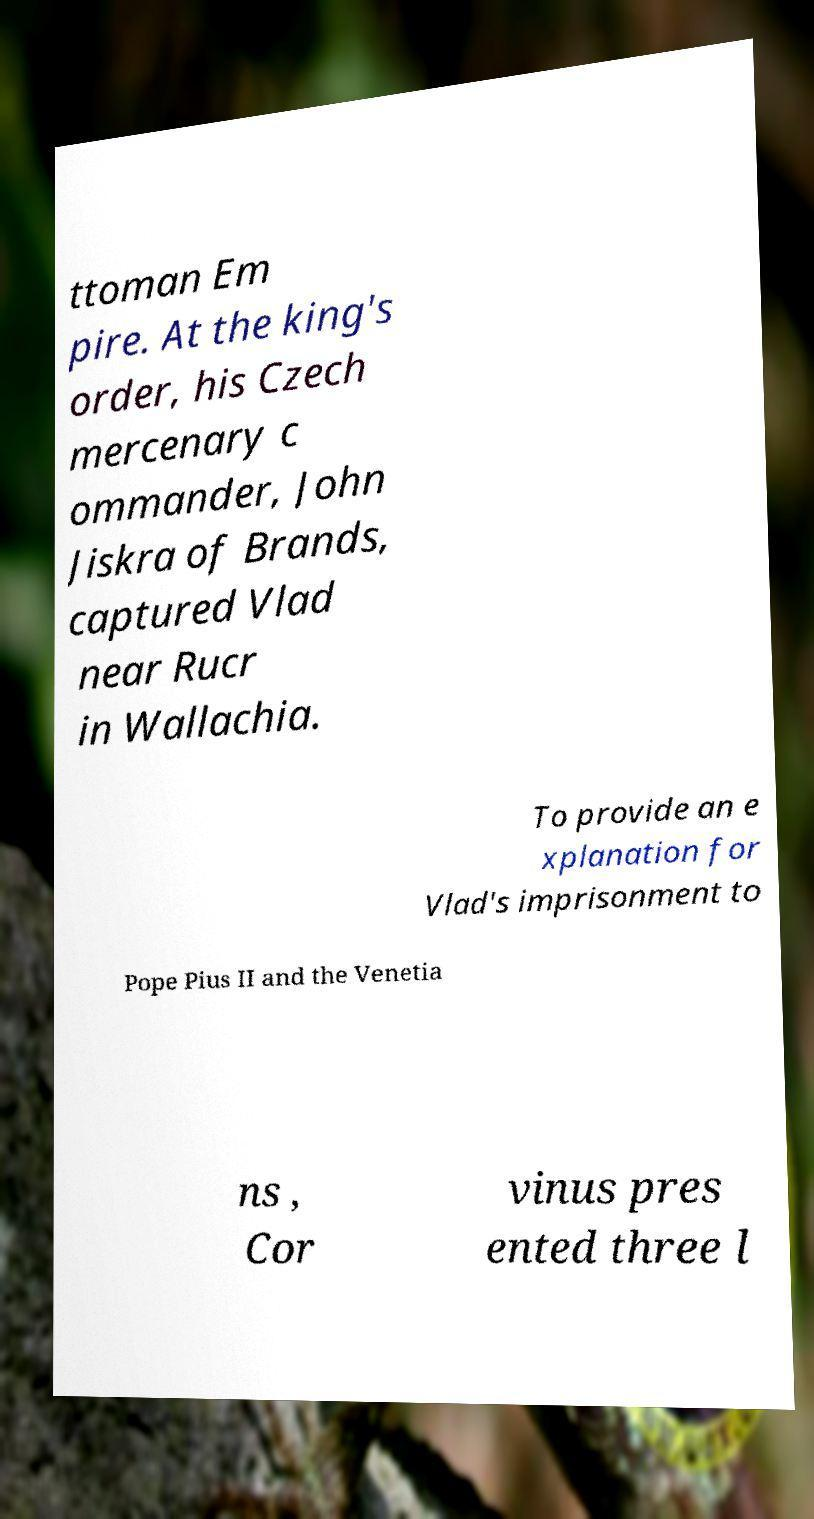I need the written content from this picture converted into text. Can you do that? ttoman Em pire. At the king's order, his Czech mercenary c ommander, John Jiskra of Brands, captured Vlad near Rucr in Wallachia. To provide an e xplanation for Vlad's imprisonment to Pope Pius II and the Venetia ns , Cor vinus pres ented three l 